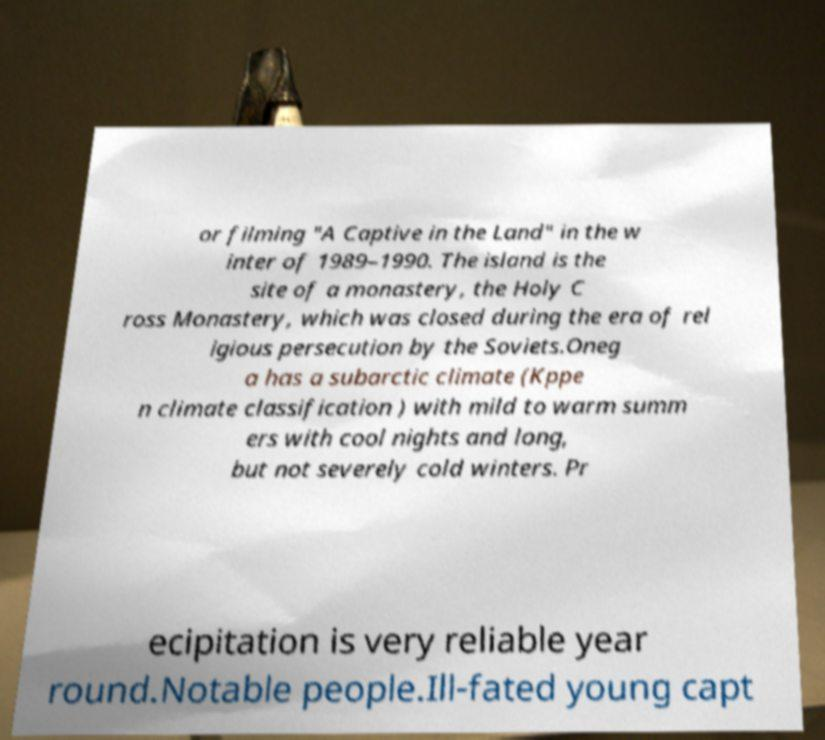Can you read and provide the text displayed in the image?This photo seems to have some interesting text. Can you extract and type it out for me? or filming "A Captive in the Land" in the w inter of 1989–1990. The island is the site of a monastery, the Holy C ross Monastery, which was closed during the era of rel igious persecution by the Soviets.Oneg a has a subarctic climate (Kppe n climate classification ) with mild to warm summ ers with cool nights and long, but not severely cold winters. Pr ecipitation is very reliable year round.Notable people.Ill-fated young capt 